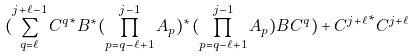<formula> <loc_0><loc_0><loc_500><loc_500>( \sum _ { q = \ell } ^ { j + \ell - 1 } { C ^ { q } } ^ { * } B ^ { * } ( \prod _ { p = q - \ell + 1 } ^ { j - 1 } A _ { p } ) ^ { * } ( \prod _ { p = q - \ell + 1 } ^ { j - 1 } A _ { p } ) B C ^ { q } ) + { C ^ { j + \ell } } ^ { * } C ^ { j + \ell }</formula> 